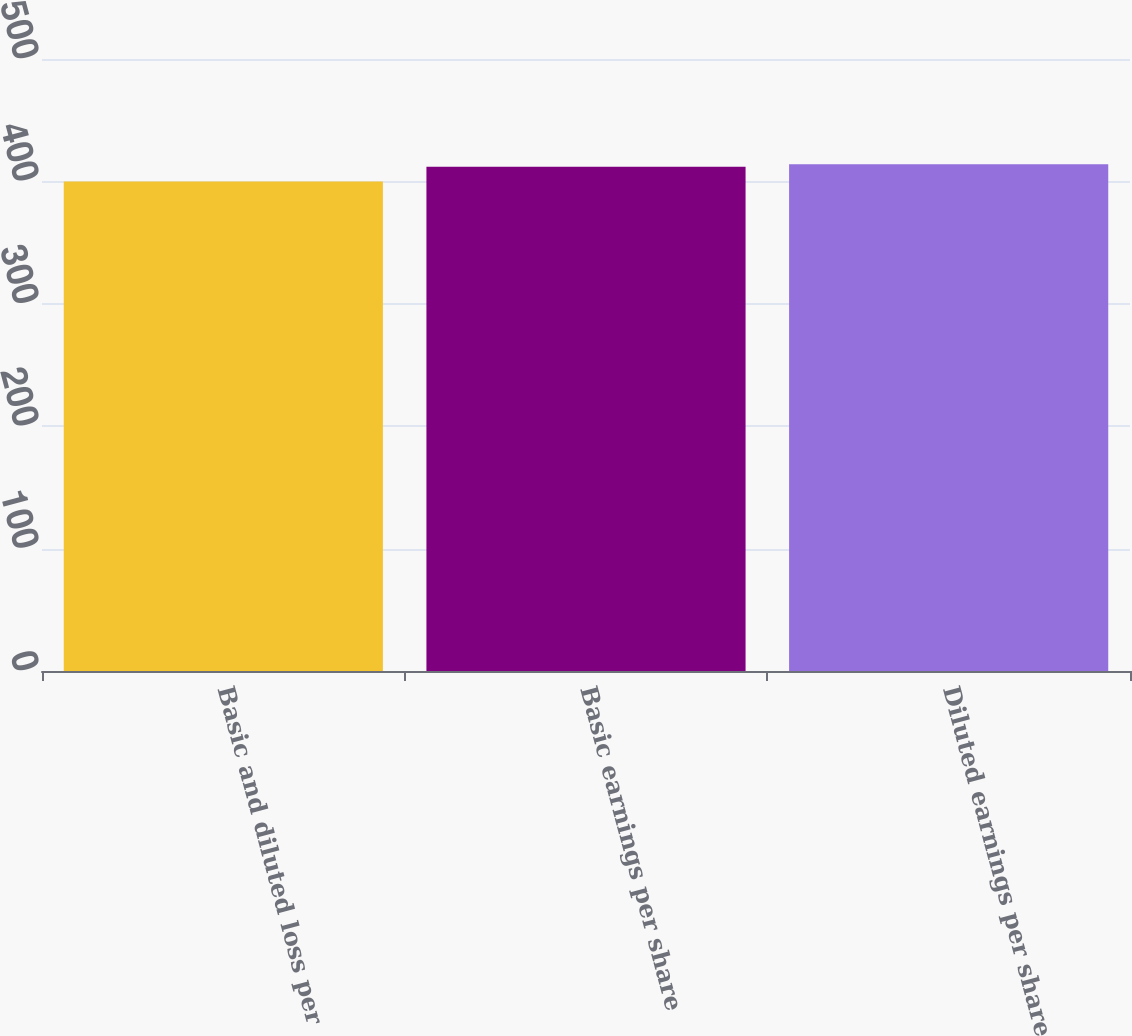<chart> <loc_0><loc_0><loc_500><loc_500><bar_chart><fcel>Basic and diluted loss per<fcel>Basic earnings per share<fcel>Diluted earnings per share<nl><fcel>400<fcel>412<fcel>414<nl></chart> 